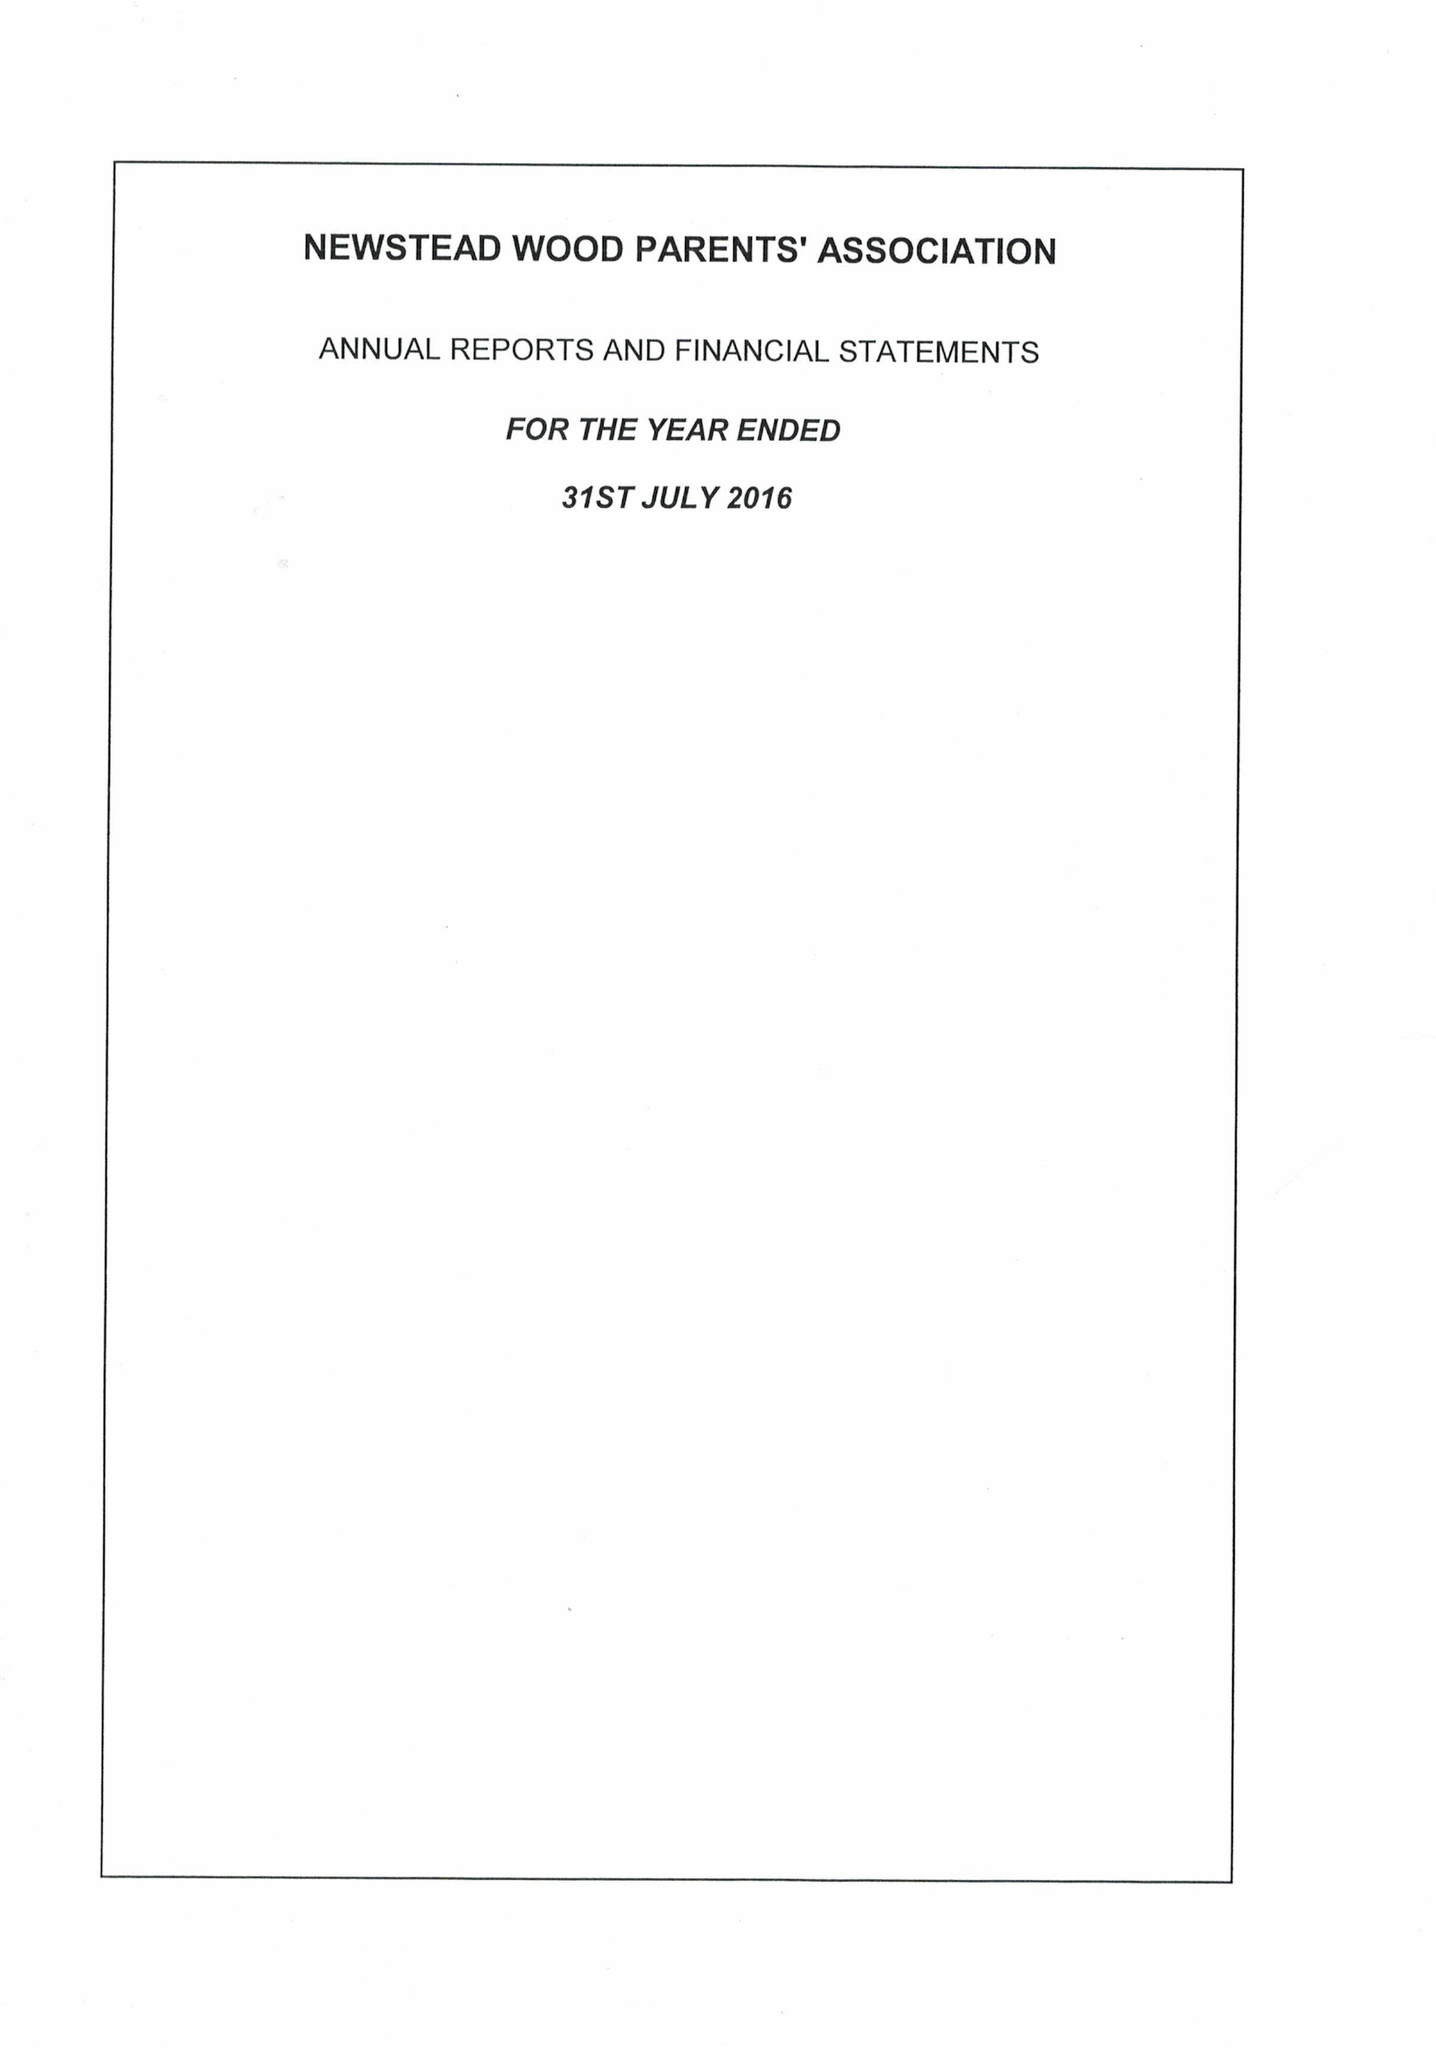What is the value for the charity_name?
Answer the question using a single word or phrase. The Newstead Wood Parents' Association 